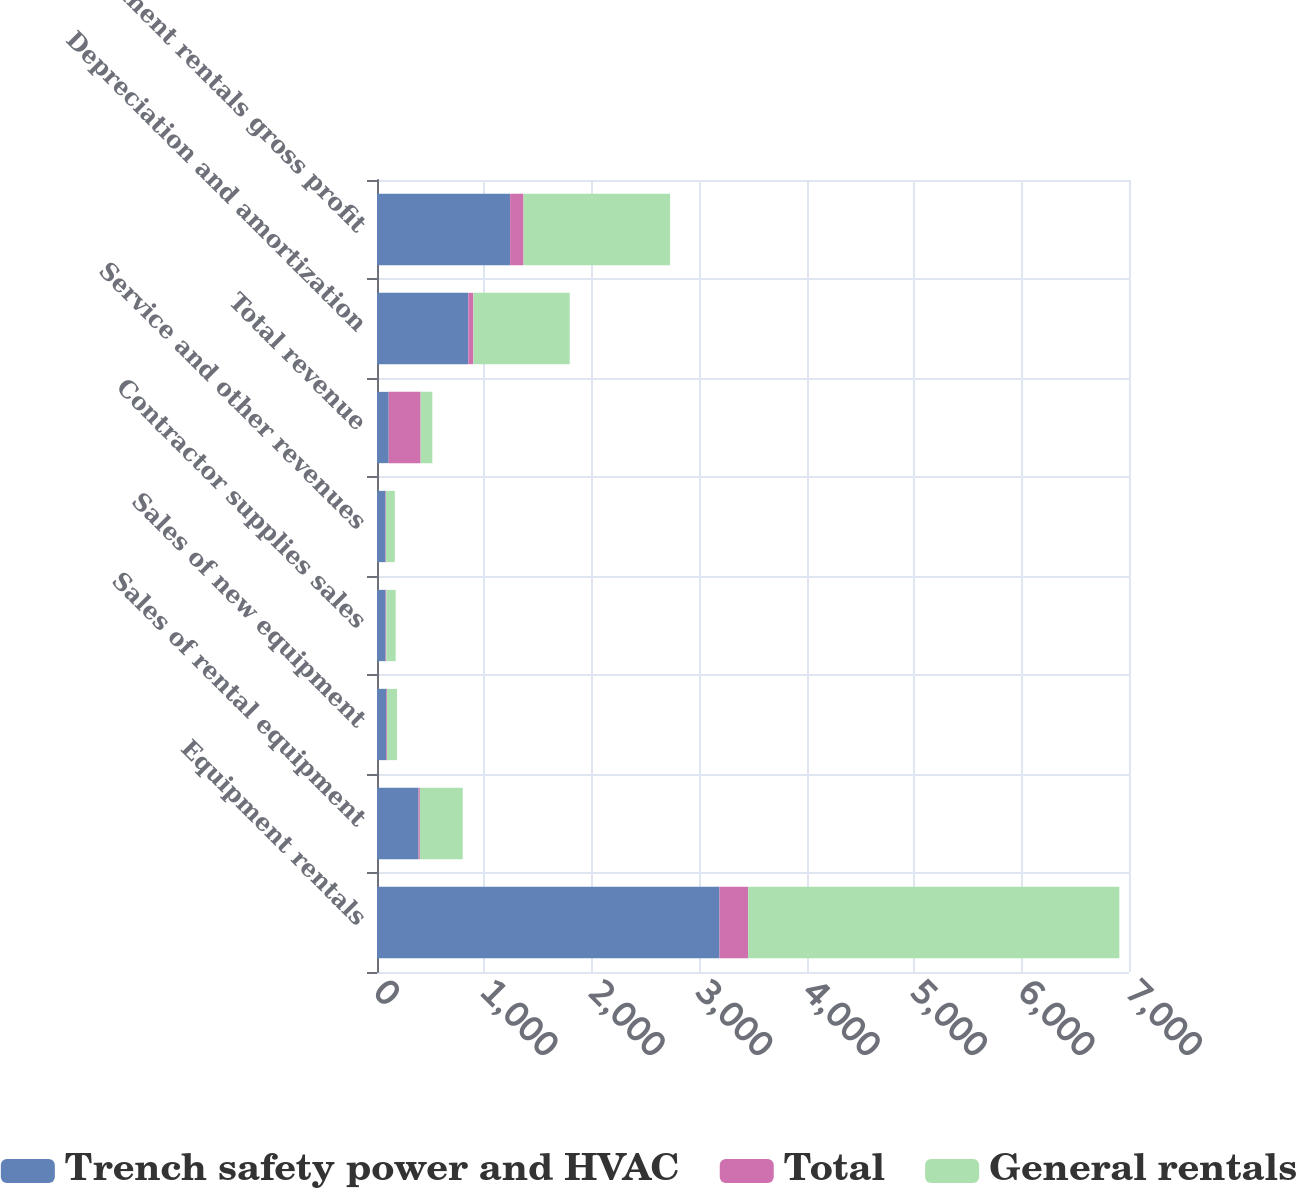Convert chart. <chart><loc_0><loc_0><loc_500><loc_500><stacked_bar_chart><ecel><fcel>Equipment rentals<fcel>Sales of rental equipment<fcel>Sales of new equipment<fcel>Contractor supplies sales<fcel>Service and other revenues<fcel>Total revenue<fcel>Depreciation and amortization<fcel>Equipment rentals gross profit<nl><fcel>Trench safety power and HVAC<fcel>3188<fcel>387<fcel>86<fcel>80<fcel>79<fcel>109<fcel>850<fcel>1239<nl><fcel>Total<fcel>267<fcel>12<fcel>7<fcel>7<fcel>4<fcel>297<fcel>47<fcel>125<nl><fcel>General rentals<fcel>3455<fcel>399<fcel>93<fcel>87<fcel>83<fcel>109<fcel>897<fcel>1364<nl></chart> 